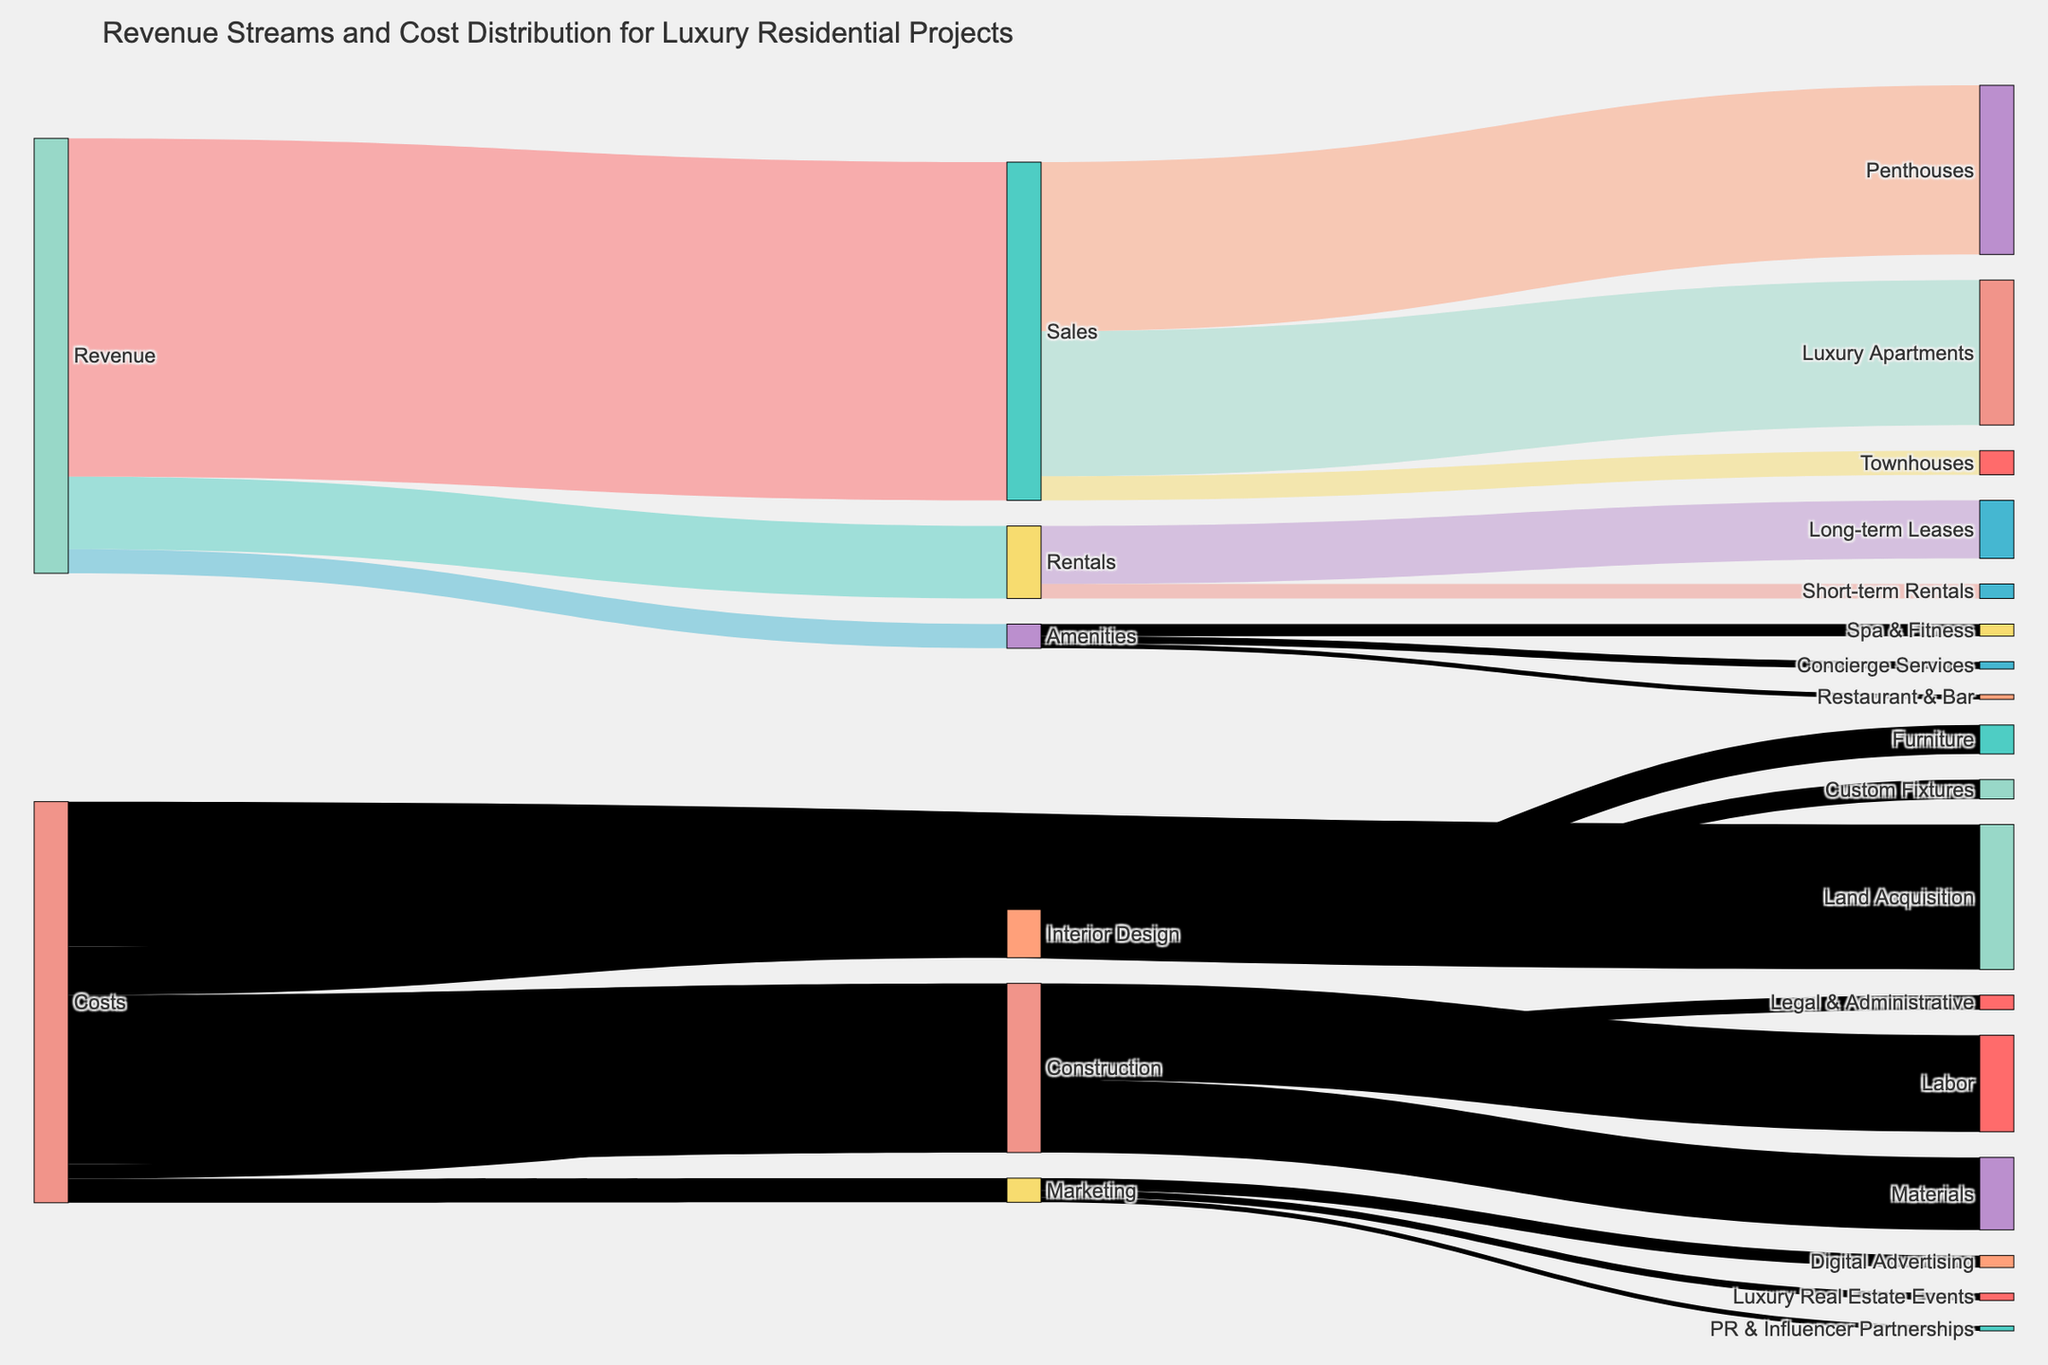What are the three main revenue streams depicted in the Sankey Diagram? The Sankey Diagram shows three main revenue streams: Sales, Rentals, and Amenities. Each of these is a distinct starting point for further subdivisions, indicating their importance in the revenue structure.
Answer: Sales, Rentals, Amenities Which revenue stream brings in the most value? By examining the figure, Sales is the largest revenue stream with a value of $70,000,000. This can be identified as the thickest link originating from Revenue in the diagram.
Answer: Sales How much revenue is generated from Short-term Rentals? The diagram shows Short-term Rentals as a subdivision of Rentals, contributing $3,000,000. This can be seen by tracing the flow from Rentals to Short-term Rentals.
Answer: $3,000,000 What are the major cost categories for the project? The major cost categories in the Sankey Diagram are Land Acquisition, Construction, Interior Design, Marketing, and Legal & Administrative. These categories can be seen branching out directly from Costs.
Answer: Land Acquisition, Construction, Interior Design, Marketing, Legal & Administrative What is the combined cost of Construction and Interior Design? The cost for Construction is $35,000,000 and for Interior Design is $10,000,000. Adding these together gives $45,000,000.
Answer: $45,000,000 Which category under Marketing has the lowest expenditure? Examining the Marketing category in the Sankey Diagram reveals that PR & Influencer Partnerships have the lowest expenditure at $1,000,000.
Answer: PR & Influencer Partnerships Which has a higher expense: Labor or Materials under Construction? Under Construction, Labor has an expense of $20,000,000, while Materials have an expense of $15,000,000. Therefore, Labor has a higher expense.
Answer: Labor What is the total value generated from sales of Luxury Apartments and Townhouses? The value from the sales of Luxury Apartments is $30,000,000 and from Townhouses is $5,000,000. Adding these together gives $35,000,000.
Answer: $35,000,000 What percentage of the total revenue does Amenities contribute? Total revenue is the sum of Sales ($70,000,000), Rentals ($15,000,000), and Amenities ($5,000,000), which equals $90,000,000. Amenities contribute $5,000,000. The percentage is calculated as ($5,000,000 / $90,000,000) * 100, which is approximately 5.56%.
Answer: ~5.56% Which has a higher investment: Land Acquisition or all Marketing activities combined? Land Acquisition has an investment of $30,000,000. The total for Marketing activities is the sum of Digital Advertising ($2,500,000), Luxury Real Estate Events ($1,500,000), and PR & Influencer Partnerships ($1,000,000), which equals $5,000,000. Since $30,000,000 (Land Acquisition) is greater than $5,000,000 (Marketing), Land Acquisition has a higher investment.
Answer: Land Acquisition 